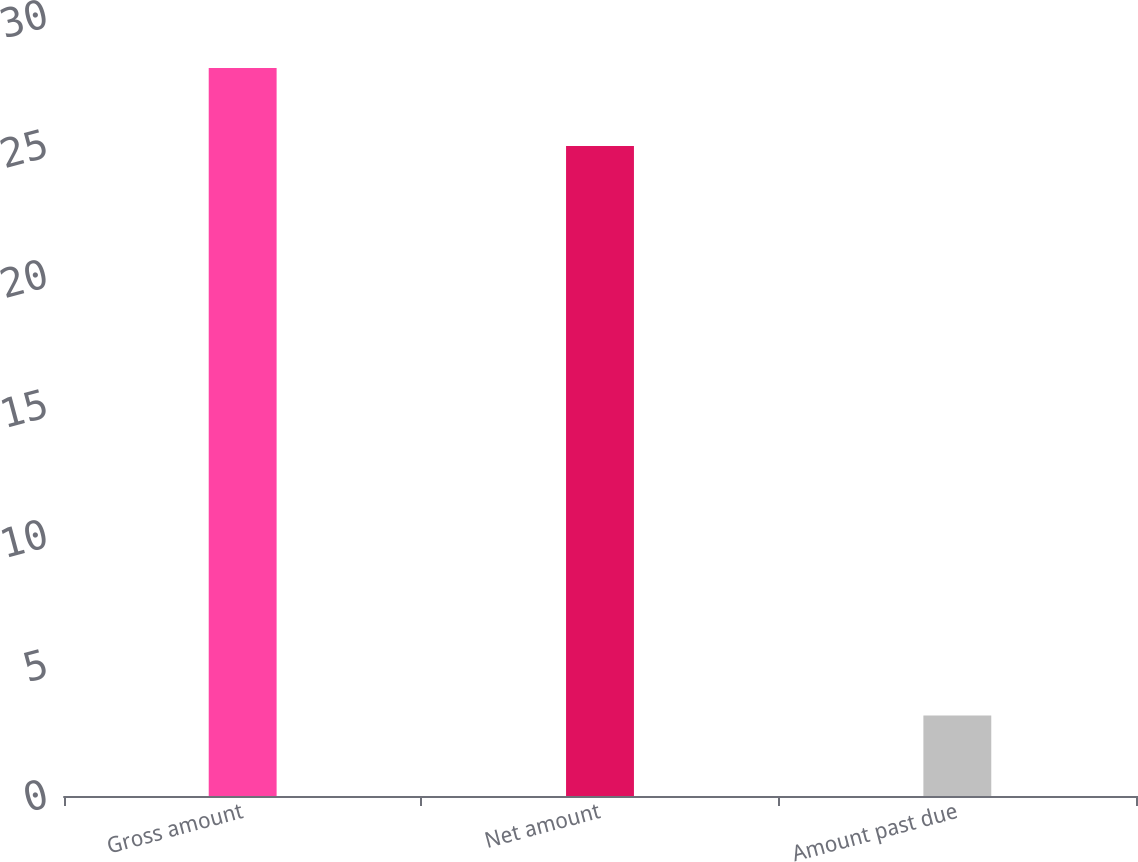Convert chart to OTSL. <chart><loc_0><loc_0><loc_500><loc_500><bar_chart><fcel>Gross amount<fcel>Net amount<fcel>Amount past due<nl><fcel>28<fcel>25<fcel>3.1<nl></chart> 